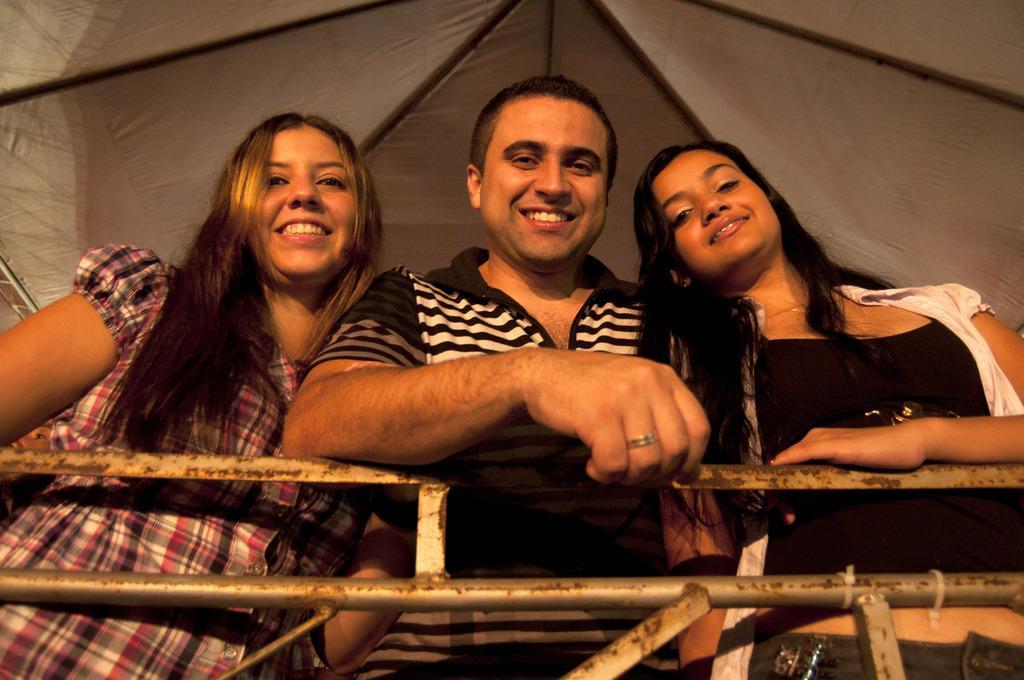How would you summarize this image in a sentence or two? In the middle of the image, there is a person in a t-shirt, smiling and keeping his elbow on a fence. On the left side, there is a woman smiling. On the right side, there is another woman smiling. In the background, there is a roof. 